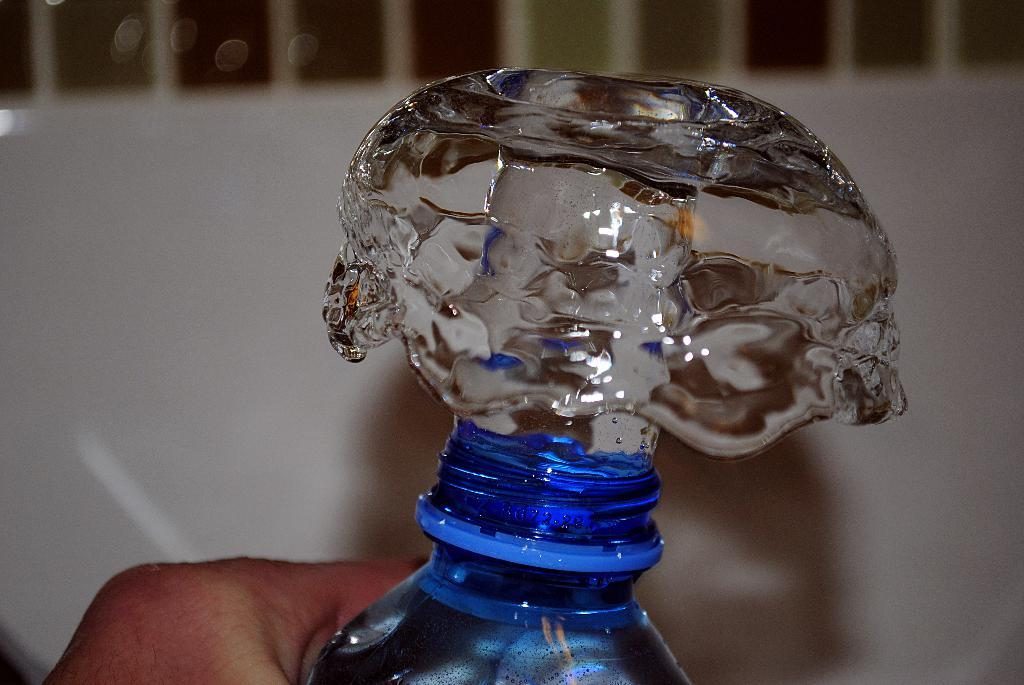What is the human doing with the water bottle in the image? The human is pressing a water bottle in the image. What is the result of the human pressing the water bottle? Water is coming out of the water bottle in the image. How many babies are present in the image? There are no babies present in the image. What type of giants can be seen in the image? There are no giants present in the image. 